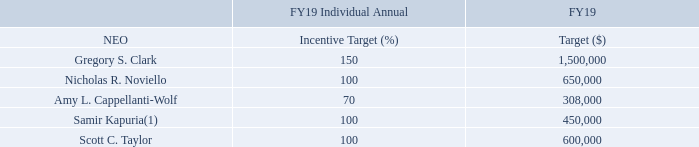Executive Annual Incentive Plan Target Opportunities: The following table presents each NEO’s target incentive opportunity for FY19 under the FY19 Executive Annual Incentive Plan (the ‘‘FY19 EAIP’’):
(1) In connection with Mr. Kapuria’s promotion, his FY19 Individual Annual Incentive Target under the FY19 EAIP increased from 60% to 100% effective May 8, 2018. Mr. Kapuria’s prorated target annual incentive value for FY19 is $427,451.
What does the table present? Each neo’s target incentive opportunity for fy19 under the fy19 executive annual incentive plan. What is Mr Kapuria's prorated target annual incentive value for FY19? $427,451. What is  Gregory S. Clark's FY19 incentive target(%)? 
Answer scale should be: percent. 150. What is the total FY19 target($) for all NEOs?  1,500,000+650,000+308,000+450,000+600,000
Answer: 3508000. What is the average FY19 target ($) for NEOs? (1,500,000+650,000+308,000+450,000+600,000)/5
Answer: 701600. Who are the NEO(s) with a FY19 target above the average? For each row for COL4 if the value>(1,500,000+650,000+308,000+450,000+600,000)/5=701,600, select corresponding NEO name as answer.
Answer: gregory s. clark. 